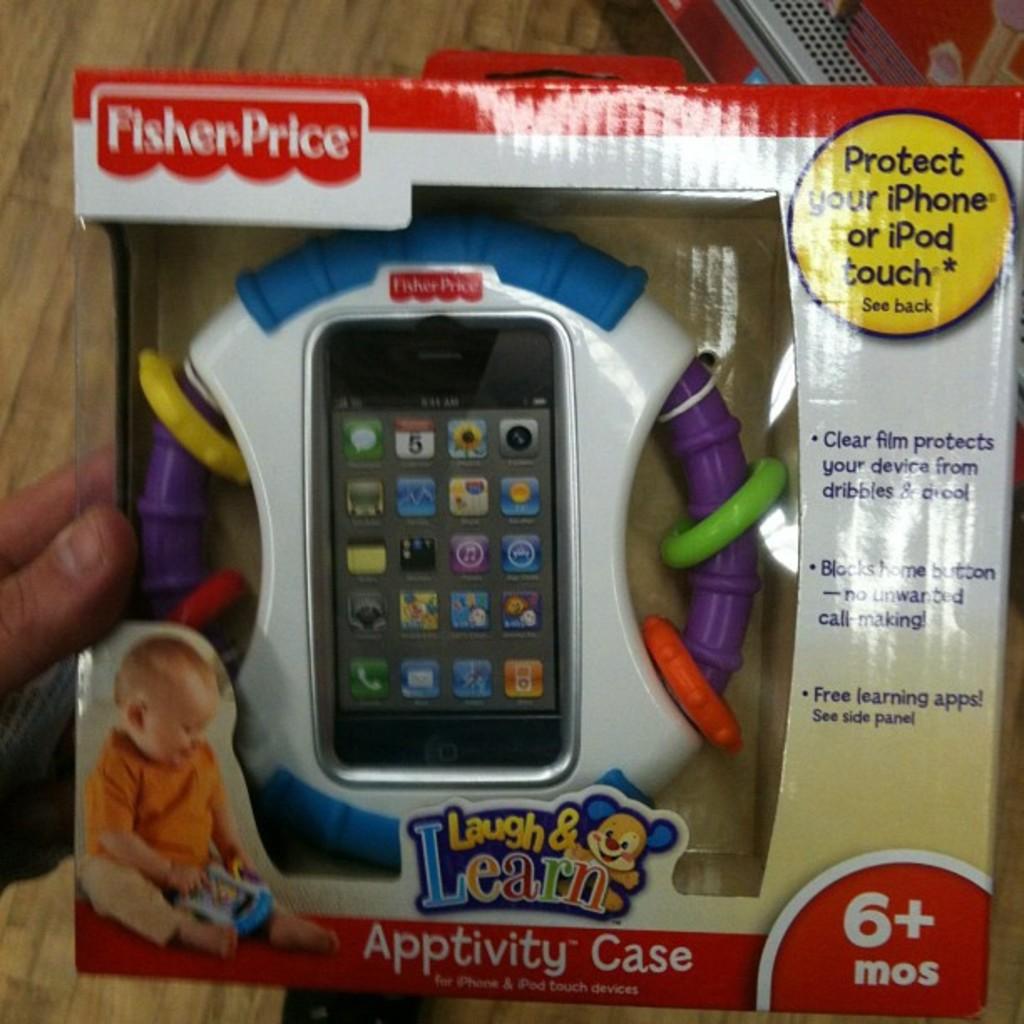What age is this toy for?
Keep it short and to the point. 6+ months. 